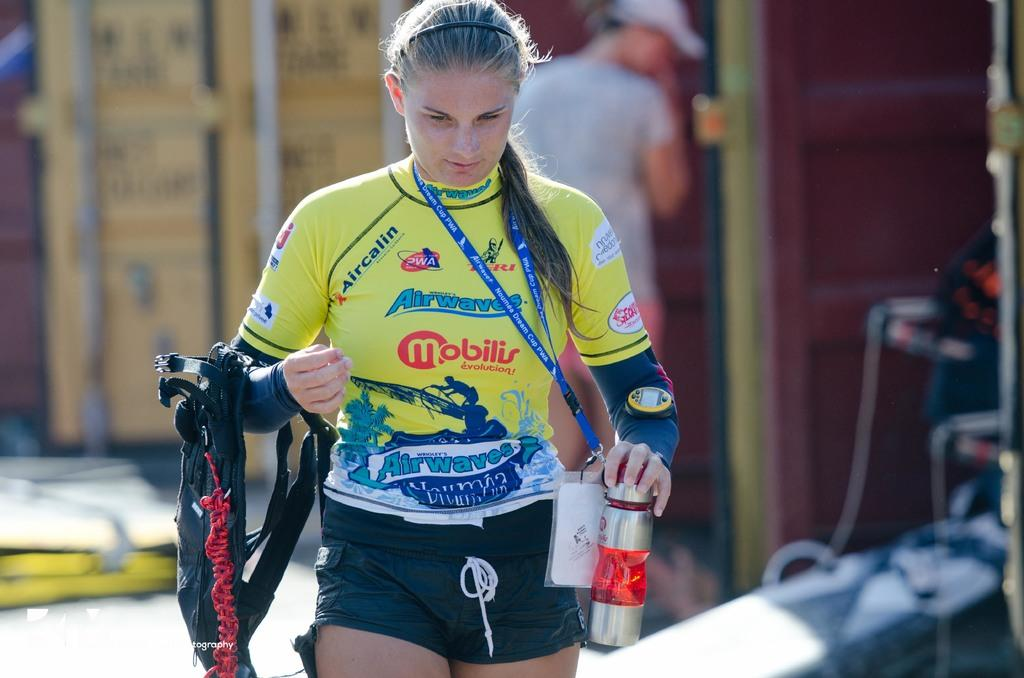<image>
Offer a succinct explanation of the picture presented. A woman in a yellow jersey with Mobilis on the front 